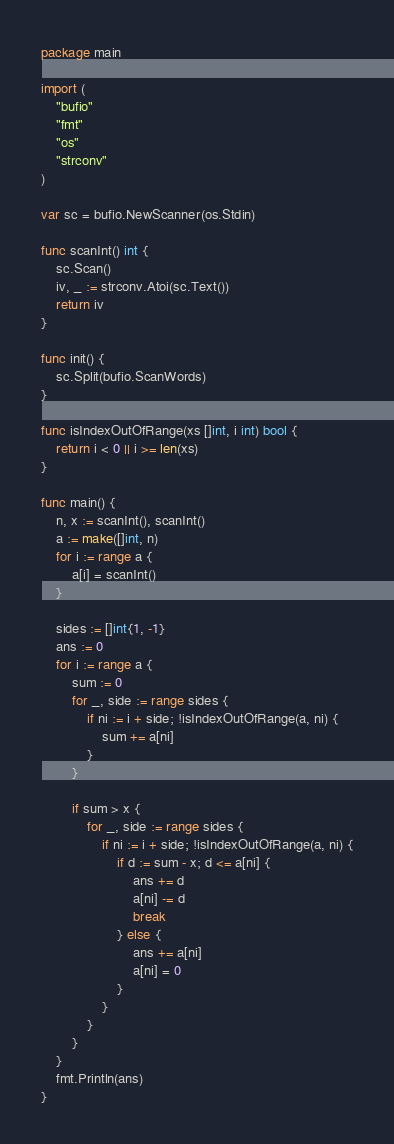Convert code to text. <code><loc_0><loc_0><loc_500><loc_500><_Go_>package main

import (
	"bufio"
	"fmt"
	"os"
	"strconv"
)

var sc = bufio.NewScanner(os.Stdin)

func scanInt() int {
	sc.Scan()
	iv, _ := strconv.Atoi(sc.Text())
	return iv
}

func init() {
	sc.Split(bufio.ScanWords)
}

func isIndexOutOfRange(xs []int, i int) bool {
	return i < 0 || i >= len(xs)
}

func main() {
	n, x := scanInt(), scanInt()
	a := make([]int, n)
	for i := range a {
		a[i] = scanInt()
	}

	sides := []int{1, -1}
	ans := 0
	for i := range a {
		sum := 0
		for _, side := range sides {
			if ni := i + side; !isIndexOutOfRange(a, ni) {
				sum += a[ni]
			}
		}

		if sum > x {
			for _, side := range sides {
				if ni := i + side; !isIndexOutOfRange(a, ni) {
					if d := sum - x; d <= a[ni] {
						ans += d
						a[ni] -= d
						break
					} else {
						ans += a[ni]
						a[ni] = 0
					}
				}
			}
		}
	}
	fmt.Println(ans)
}
</code> 